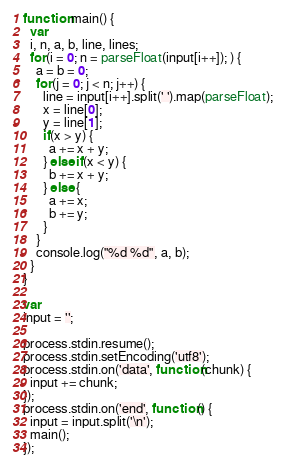Convert code to text. <code><loc_0><loc_0><loc_500><loc_500><_JavaScript_>function main() {
  var
  i, n, a, b, line, lines;
  for(i = 0; n = parseFloat(input[i++]); ) {
    a = b = 0;
    for(j = 0; j < n; j++) {
      line = input[i++].split(' ').map(parseFloat);
      x = line[0];
      y = line[1];
      if(x > y) {
        a += x + y;
      } else if(x < y) {
        b += x + y;
      } else {
        a += x;
        b += y;
      }
    }
    console.log("%d %d", a, b);
  }
}

var
input = '';

process.stdin.resume();
process.stdin.setEncoding('utf8');
process.stdin.on('data', function(chunk) {
  input += chunk;
});
process.stdin.on('end', function() {
  input = input.split('\n');
  main();
});</code> 